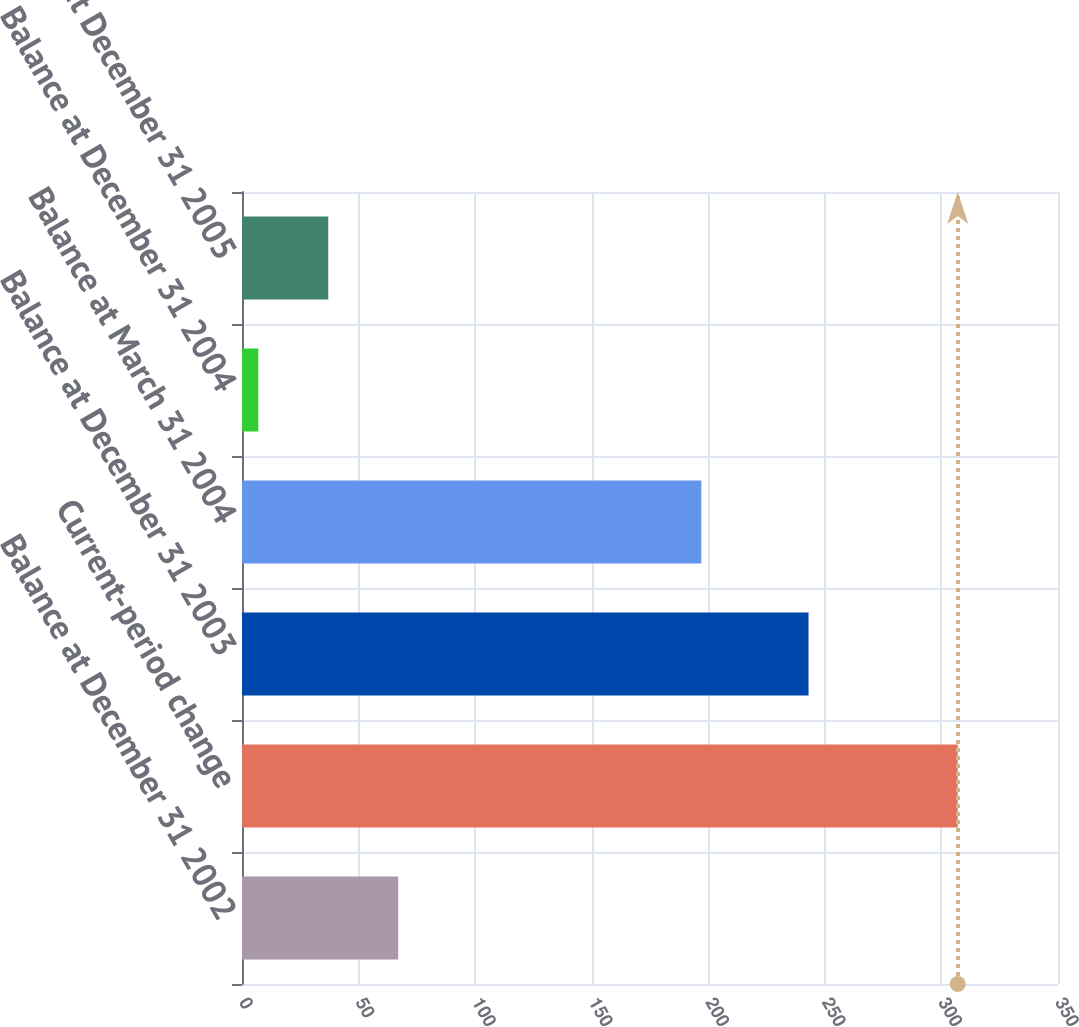Convert chart. <chart><loc_0><loc_0><loc_500><loc_500><bar_chart><fcel>Balance at December 31 2002<fcel>Current-period change<fcel>Balance at December 31 2003<fcel>Balance at March 31 2004<fcel>Balance at December 31 2004<fcel>Balance at December 31 2005<nl><fcel>67<fcel>307<fcel>243<fcel>197<fcel>7<fcel>37<nl></chart> 